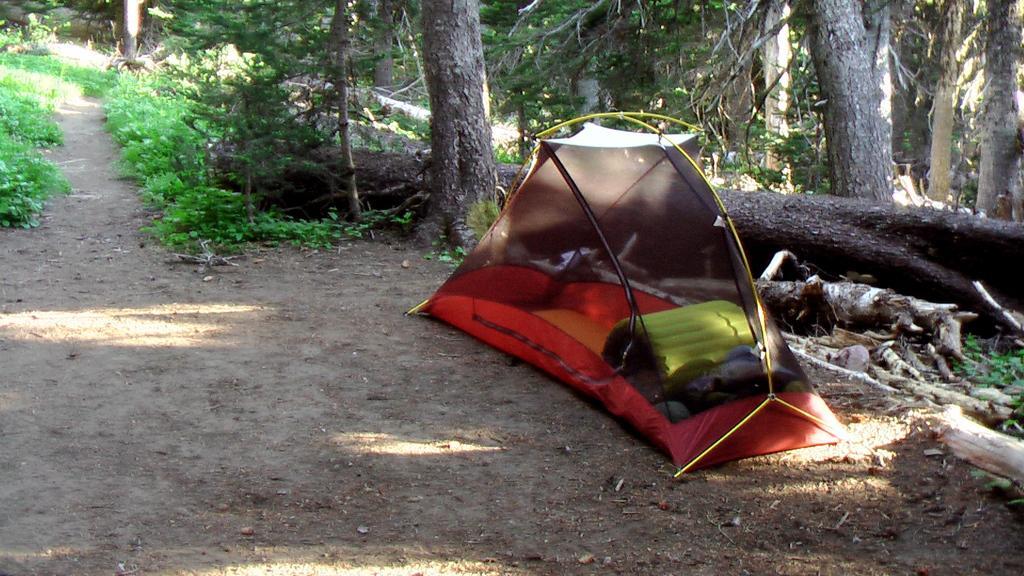Please provide a concise description of this image. In the front of the image we can see a tent. Inside the tent there are things. In the background of the image there are plants and trees.  